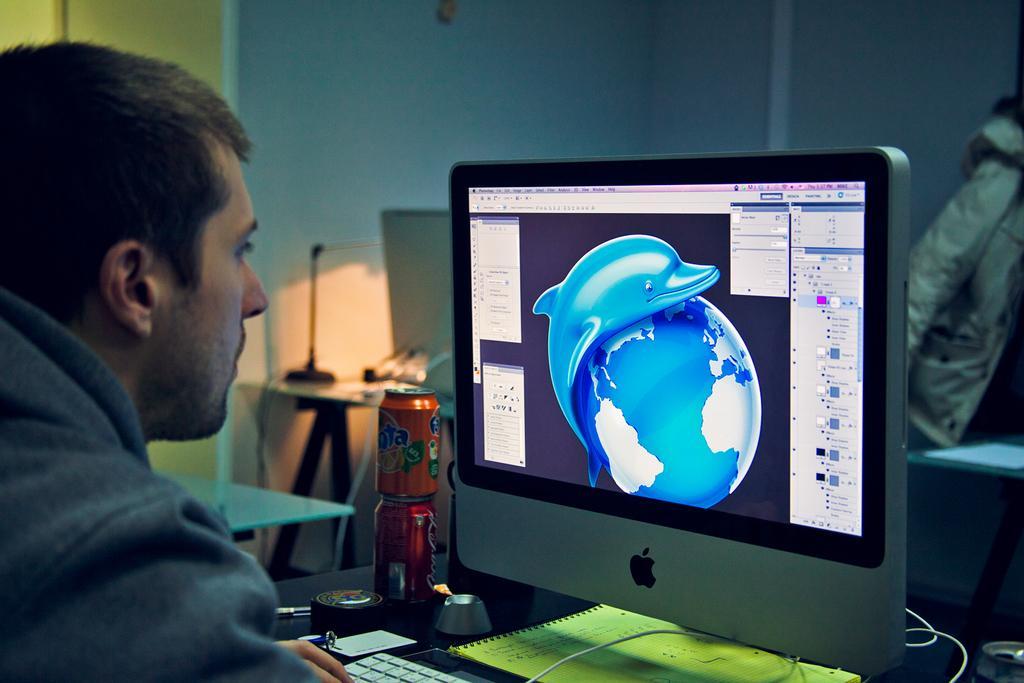Could you give a brief overview of what you see in this image? On the left side, there is a person in a shirt sitting in front of table on which, there is a screen, keyboard, tins and other objects. In the background, there is another table on which there is a light and other objects, there is a white color table and there is wall. 